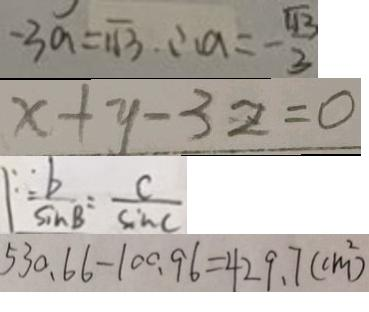<formula> <loc_0><loc_0><loc_500><loc_500>- 3 a = \sqrt { 1 3 } . \therefore a = - \frac { \sqrt { 1 3 } } { 3 } 
 x + y - 3 z = 0 
 \because \frac { b } { \sin B } = \frac { c } { \sin C } 
 5 3 0 . 6 6 - 1 0 0 . 9 6 = 4 2 9 . 7 ( c m ^ { 2 } )</formula> 